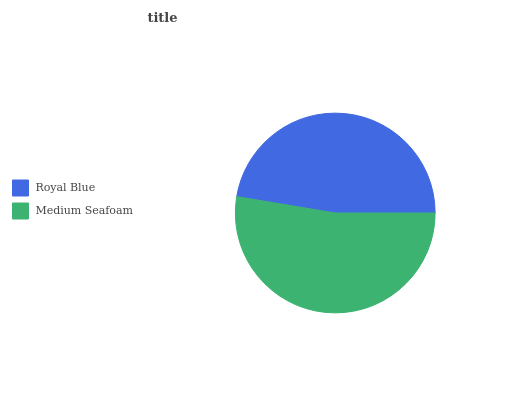Is Royal Blue the minimum?
Answer yes or no. Yes. Is Medium Seafoam the maximum?
Answer yes or no. Yes. Is Medium Seafoam the minimum?
Answer yes or no. No. Is Medium Seafoam greater than Royal Blue?
Answer yes or no. Yes. Is Royal Blue less than Medium Seafoam?
Answer yes or no. Yes. Is Royal Blue greater than Medium Seafoam?
Answer yes or no. No. Is Medium Seafoam less than Royal Blue?
Answer yes or no. No. Is Medium Seafoam the high median?
Answer yes or no. Yes. Is Royal Blue the low median?
Answer yes or no. Yes. Is Royal Blue the high median?
Answer yes or no. No. Is Medium Seafoam the low median?
Answer yes or no. No. 